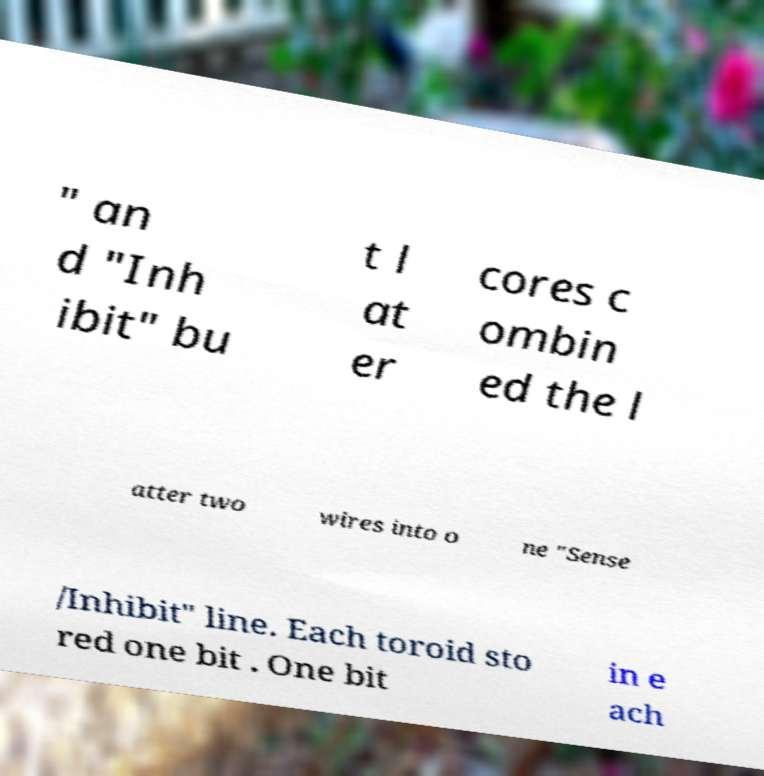Please read and relay the text visible in this image. What does it say? " an d "Inh ibit" bu t l at er cores c ombin ed the l atter two wires into o ne "Sense /Inhibit" line. Each toroid sto red one bit . One bit in e ach 